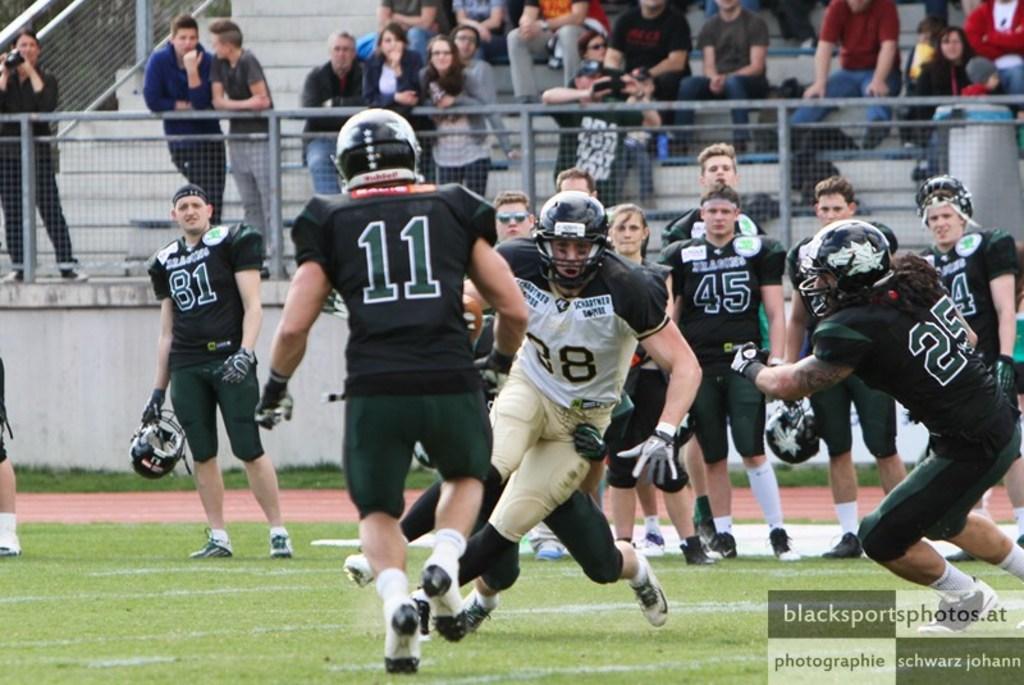Can you describe this image briefly? In this picture we can see few people on the ground and in the background we can see a group of people, fence and steps, in the bottom right we can see some text. 